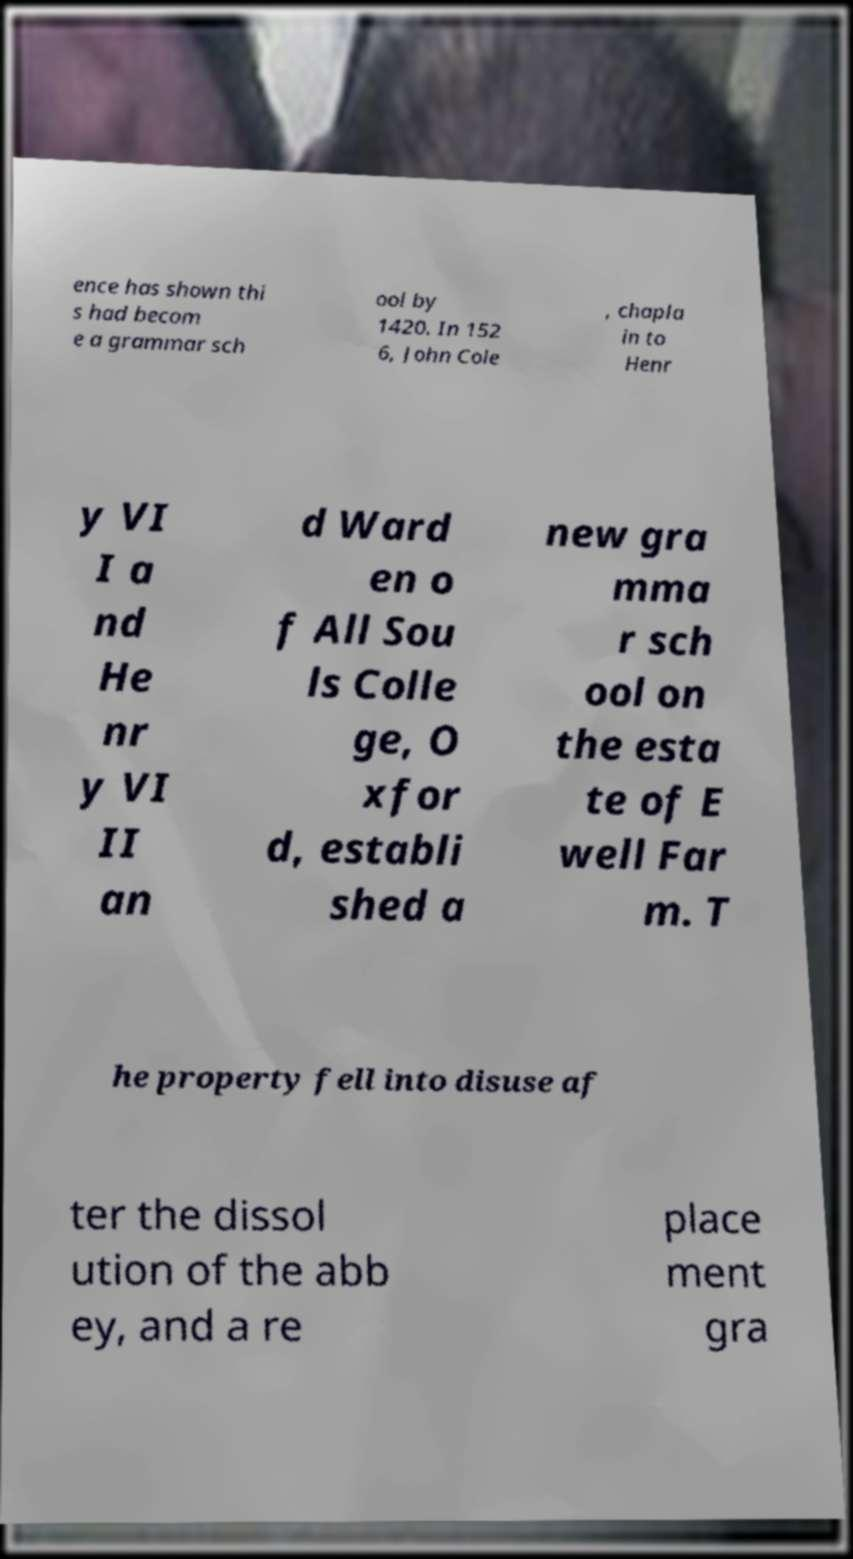For documentation purposes, I need the text within this image transcribed. Could you provide that? ence has shown thi s had becom e a grammar sch ool by 1420. In 152 6, John Cole , chapla in to Henr y VI I a nd He nr y VI II an d Ward en o f All Sou ls Colle ge, O xfor d, establi shed a new gra mma r sch ool on the esta te of E well Far m. T he property fell into disuse af ter the dissol ution of the abb ey, and a re place ment gra 